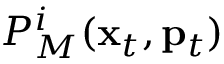<formula> <loc_0><loc_0><loc_500><loc_500>P _ { M } ^ { i } ( { x } _ { t } , { p } _ { t } )</formula> 